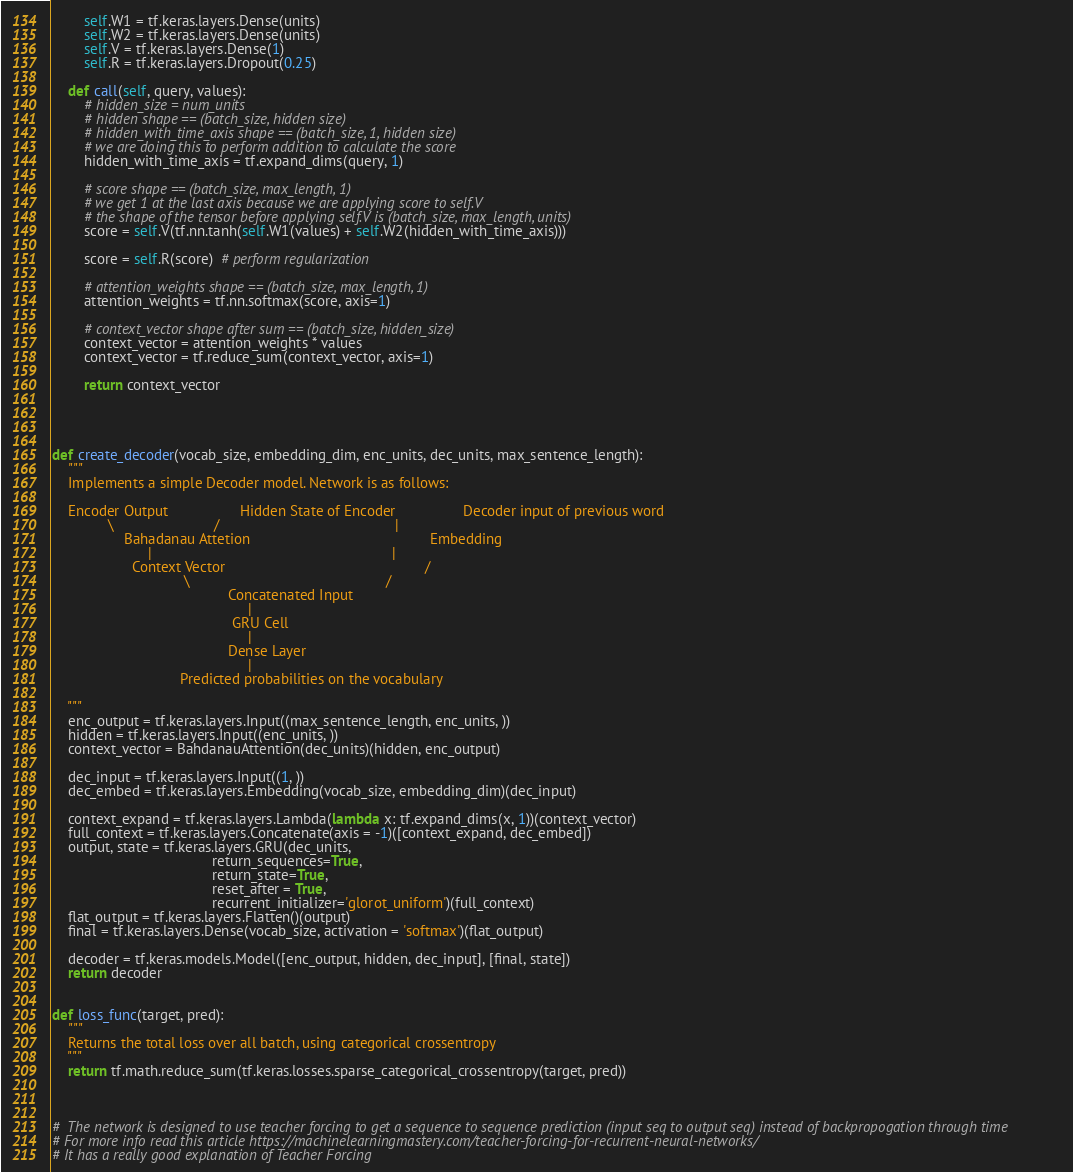<code> <loc_0><loc_0><loc_500><loc_500><_Python_>        self.W1 = tf.keras.layers.Dense(units)
        self.W2 = tf.keras.layers.Dense(units)
        self.V = tf.keras.layers.Dense(1)
        self.R = tf.keras.layers.Dropout(0.25)
        
    def call(self, query, values):
        # hidden_size = num_units
        # hidden shape == (batch_size, hidden size)
        # hidden_with_time_axis shape == (batch_size, 1, hidden size)
        # we are doing this to perform addition to calculate the score
        hidden_with_time_axis = tf.expand_dims(query, 1)

        # score shape == (batch_size, max_length, 1)
        # we get 1 at the last axis because we are applying score to self.V
        # the shape of the tensor before applying self.V is (batch_size, max_length, units)
        score = self.V(tf.nn.tanh(self.W1(values) + self.W2(hidden_with_time_axis)))
        
        score = self.R(score)  # perform regularization

        # attention_weights shape == (batch_size, max_length, 1)
        attention_weights = tf.nn.softmax(score, axis=1)

        # context_vector shape after sum == (batch_size, hidden_size)
        context_vector = attention_weights * values
        context_vector = tf.reduce_sum(context_vector, axis=1)

        return context_vector



    
def create_decoder(vocab_size, embedding_dim, enc_units, dec_units, max_sentence_length):
    """
    Implements a simple Decoder model. Network is as follows:
    
    Encoder Output                  Hidden State of Encoder                 Decoder input of previous word
              \                         /                                            |                                                      
                  Bahadanau Attetion                                             Embedding
                        |                                                            | 
                    Context Vector                                                  /
                                 \                                                 /
                                            Concatenated Input
                                                 |
                                             GRU Cell
                                                 |
                                            Dense Layer
                                                 |
                                Predicted probabilities on the vocabulary
        
    """
    enc_output = tf.keras.layers.Input((max_sentence_length, enc_units, ))
    hidden = tf.keras.layers.Input((enc_units, ))
    context_vector = BahdanauAttention(dec_units)(hidden, enc_output)
    
    dec_input = tf.keras.layers.Input((1, ))
    dec_embed = tf.keras.layers.Embedding(vocab_size, embedding_dim)(dec_input)
    
    context_expand = tf.keras.layers.Lambda(lambda x: tf.expand_dims(x, 1))(context_vector)
    full_context = tf.keras.layers.Concatenate(axis = -1)([context_expand, dec_embed])
    output, state = tf.keras.layers.GRU(dec_units, 
                                        return_sequences=True, 
                                        return_state=True,
                                        reset_after = True,
                                        recurrent_initializer='glorot_uniform')(full_context)
    flat_output = tf.keras.layers.Flatten()(output)
    final = tf.keras.layers.Dense(vocab_size, activation = 'softmax')(flat_output)
    
    decoder = tf.keras.models.Model([enc_output, hidden, dec_input], [final, state])
    return decoder


def loss_func(target, pred):
    """
    Returns the total loss over all batch, using categorical crossentropy
    """
    return tf.math.reduce_sum(tf.keras.losses.sparse_categorical_crossentropy(target, pred))



#  The network is designed to use teacher forcing to get a sequence to sequence prediction (input seq to output seq) instead of backpropogation through time
# For more info read this article https://machinelearningmastery.com/teacher-forcing-for-recurrent-neural-networks/
# It has a really good explanation of Teacher Forcing
</code> 